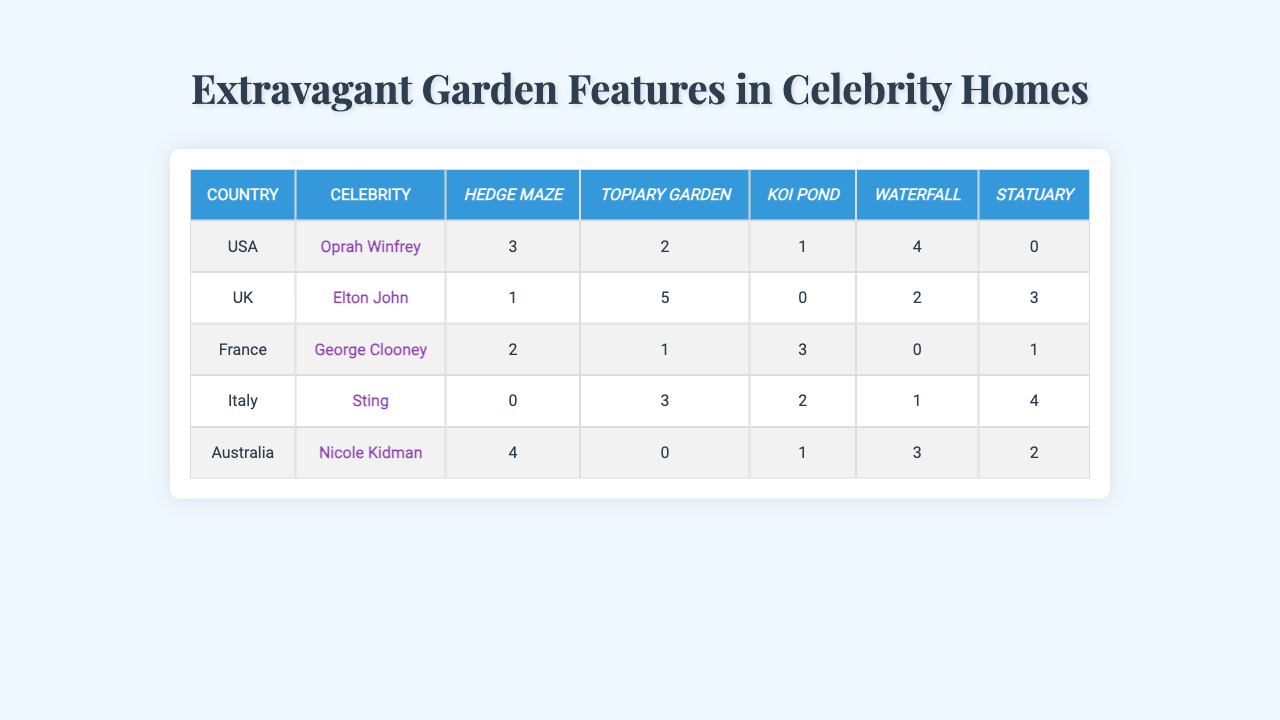What is the total number of extravagant features owned by Oprah Winfrey? Oprah Winfrey's row in the table shows values for five features: Hedge Maze (3), Topiary Garden (2), Koi Pond (1), Waterfall (4), and Statuary (0). Summing these gives us 3 + 2 + 1 + 4 + 0 = 10.
Answer: 10 In which country does Sting have the highest number of garden features? Sting's row indicates the counts for various features: Hedge Maze (0), Topiary Garden (3), Koi Pond (2), Waterfall (1), and Statuary (4). The highest count is for Statuary (4), which he has in Italy.
Answer: Italy True or False: Nicole Kidman has more Koi Ponds than Topiary Gardens in her garden. Looking at Nicole Kidman's row, she has Koi Pond (1) and Topiary Garden (0). Since 1 (Koi Pond) is greater than 0 (Topiary Garden), the statement is true.
Answer: True What is the average number of Waterfalls across all celebrities? The values for Waterfalls are: Oprah Winfrey (4), Elton John (2), George Clooney (0), Sting (1), and Nicole Kidman (3). Adding these gives 4 + 2 + 0 + 1 + 3 = 10. Since there are 5 celebrities, the average is 10/5 = 2.
Answer: 2 Which celebrity has the least extravagant features in their garden? By comparing the sums of features for each celebrity, we find: Oprah Winfrey (10), Elton John (11), George Clooney (6), Sting (10), and Nicole Kidman (7). The lowest total is for George Clooney with a sum of 6.
Answer: George Clooney How many more Topiary Gardens does Elton John have than Nicole Kidman? Elton John has 5 Topiary Gardens and Nicole Kidman has 0. The difference is 5 - 0 = 5.
Answer: 5 Which country has the highest overall number of Waterfalls among celebrities? Summing the Waterfalls by country gives: USA (4), UK (2), France (0), Italy (1), and Australia (3). The highest sum is 4 (USA), indicating the USA has the most Waterfalls.
Answer: USA If we only consider the UK and Australia, which country has more total extravagant features? The total for the UK (1 + 5 + 0 + 2 + 3 = 11) and Australia (4 + 0 + 1 + 3 + 2 = 10) shows that the UK has 11 and Australia has 10. The difference is UK > Australia.
Answer: UK Are there any countries where no celebrity has a Koi Pond? Looking at Koi Pond values: USA (1), UK (0), France (3), Italy (2), Australia (1). The UK has 0, indicating that there is at least one country without a Koi Pond.
Answer: Yes What is the total count of all extravagant features in France? For the features in France: Hedge Maze (2), Topiary Garden (1), Koi Pond (3), Waterfall (0), Statuary (1), the total sum is 2 + 1 + 3 + 0 + 1 = 7.
Answer: 7 